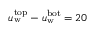<formula> <loc_0><loc_0><loc_500><loc_500>u _ { w } ^ { t o p } - u _ { w } ^ { b o t } = 2 0</formula> 